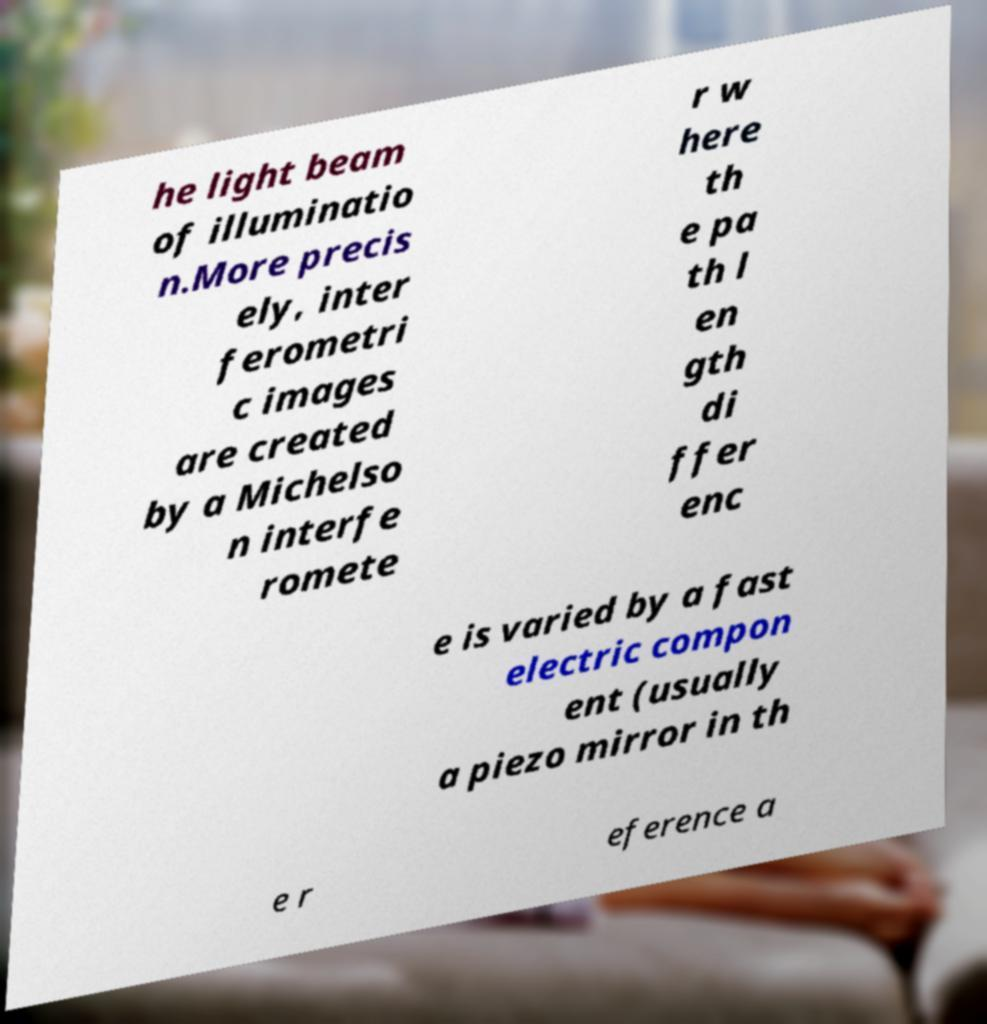I need the written content from this picture converted into text. Can you do that? he light beam of illuminatio n.More precis ely, inter ferometri c images are created by a Michelso n interfe romete r w here th e pa th l en gth di ffer enc e is varied by a fast electric compon ent (usually a piezo mirror in th e r eference a 